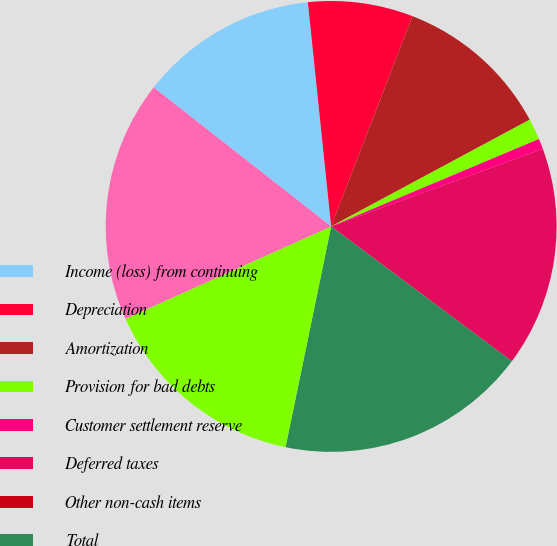<chart> <loc_0><loc_0><loc_500><loc_500><pie_chart><fcel>Income (loss) from continuing<fcel>Depreciation<fcel>Amortization<fcel>Provision for bad debts<fcel>Customer settlement reserve<fcel>Deferred taxes<fcel>Other non-cash items<fcel>Total<fcel>Receivables<fcel>Inventories<nl><fcel>12.78%<fcel>7.52%<fcel>11.28%<fcel>1.51%<fcel>0.75%<fcel>15.79%<fcel>0.0%<fcel>18.04%<fcel>15.04%<fcel>17.29%<nl></chart> 